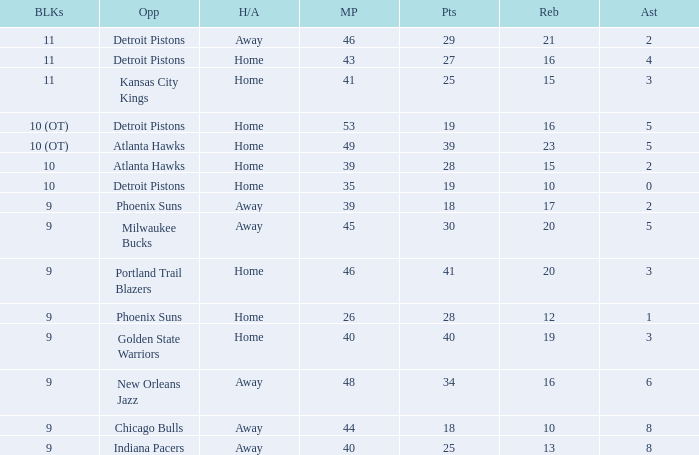How many points were there when there were less than 16 rebounds and 5 assists? 0.0. 